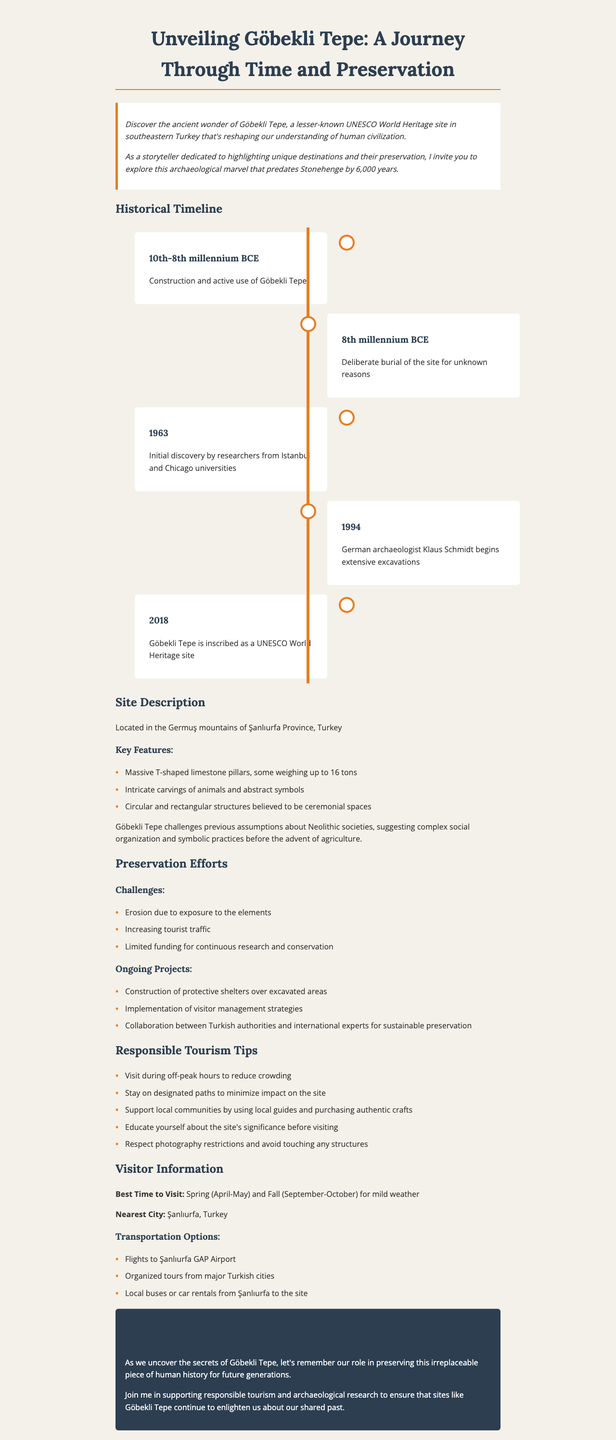What is Göbekli Tepe? Göbekli Tepe is described as an ancient wonder and a lesser-known UNESCO World Heritage site in southeastern Turkey.
Answer: An ancient wonder What year was Göbekli Tepe inscribed as a UNESCO World Heritage site? The document states that Göbekli Tepe was inscribed in the year 2018.
Answer: 2018 What are the two periods mentioned regarding Göbekli Tepe's historical timeline? The historical timeline lists the periods from the 10th-8th millennium BCE and the 8th millennium BCE in conjunction with significant events at the site.
Answer: 10th-8th millennium BCE, 8th millennium BCE What type of structures are found at Göbekli Tepe? The site features circular and rectangular structures believed to be ceremonial spaces.
Answer: Ceremonial spaces What is one challenge mentioned regarding the preservation of Göbekli Tepe? One of the challenges mentioned for preserving Göbekli Tepe is erosion due to exposure to the elements.
Answer: Erosion What is the best time to visit Göbekli Tepe? The document suggests that Spring (April-May) and Fall (September-October) are the best times to visit.
Answer: Spring (April-May) and Fall (September-October) What type of tourism does the document advocate for? The newsletter encourages responsible tourism to ensure the preservation of sites like Göbekli Tepe.
Answer: Responsible tourism What significant event happened in 1994 related to Göbekli Tepe? The document states that German archaeologist Klaus Schmidt began extensive excavations at Göbekli Tepe in 1994.
Answer: Extensive excavations What is a unique aspect of Göbekli Tepe highlighted in the document? The unique aspect is its challenge to previous assumptions about Neolithic societies, indicating complex social organization.
Answer: Complex social organization 